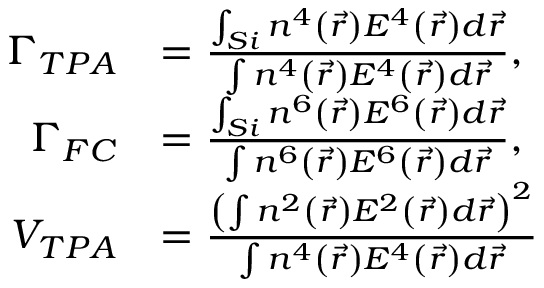Convert formula to latex. <formula><loc_0><loc_0><loc_500><loc_500>\begin{array} { r l } { \Gamma _ { T P A } } & { = \frac { \int _ { S i } n ^ { 4 } \left ( \vec { r } \right ) E ^ { 4 } \left ( \vec { r } \right ) d \vec { r } } { \int n ^ { 4 } \left ( \vec { r } \right ) E ^ { 4 } \left ( \vec { r } \right ) d \vec { r } } , } \\ { \Gamma _ { F C } } & { = \frac { \int _ { S i } n ^ { 6 } \left ( \vec { r } \right ) E ^ { 6 } \left ( \vec { r } \right ) d \vec { r } } { \int n ^ { 6 } \left ( \vec { r } \right ) E ^ { 6 } \left ( \vec { r } \right ) d \vec { r } } , } \\ { V _ { T P A } } & { = \frac { \left ( \int n ^ { 2 } \left ( \vec { r } \right ) E ^ { 2 } \left ( \vec { r } \right ) d \vec { r } \right ) ^ { 2 } } { \int n ^ { 4 } \left ( \vec { r } \right ) E ^ { 4 } \left ( \vec { r } \right ) d \vec { r } } } \end{array}</formula> 